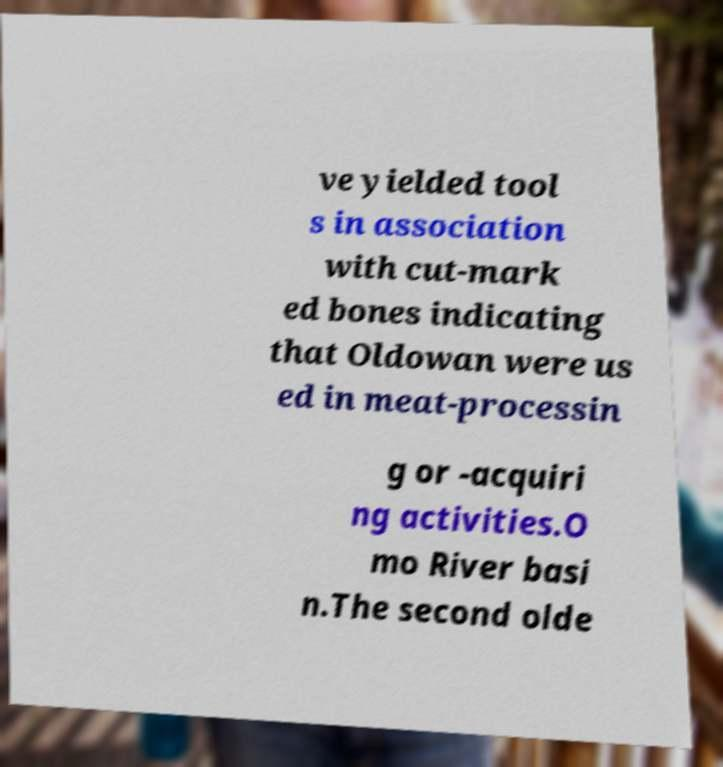Can you read and provide the text displayed in the image?This photo seems to have some interesting text. Can you extract and type it out for me? ve yielded tool s in association with cut-mark ed bones indicating that Oldowan were us ed in meat-processin g or -acquiri ng activities.O mo River basi n.The second olde 